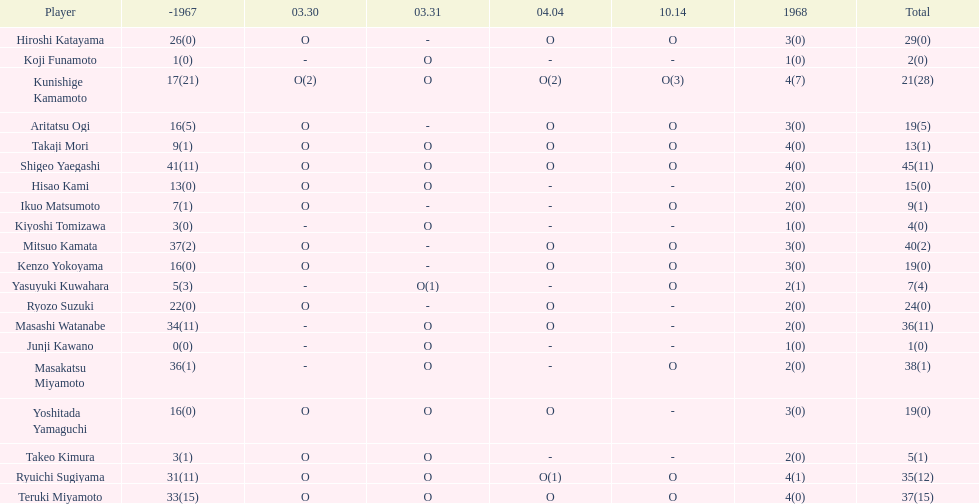Who had more points takaji mori or junji kawano? Takaji Mori. 